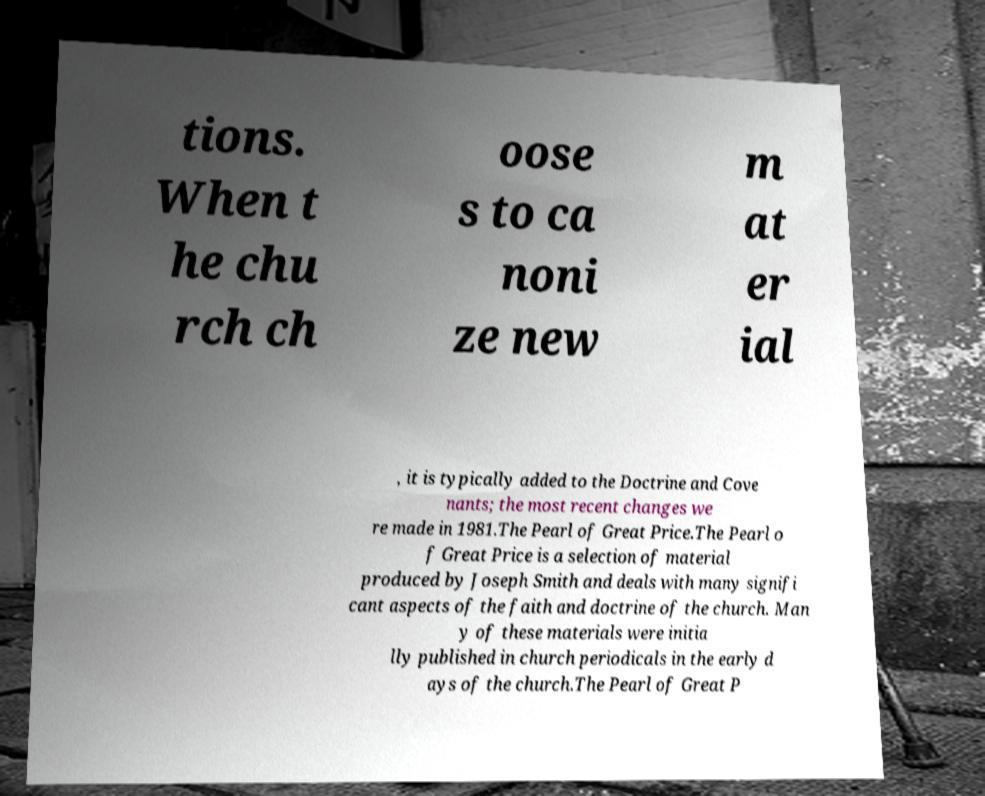I need the written content from this picture converted into text. Can you do that? tions. When t he chu rch ch oose s to ca noni ze new m at er ial , it is typically added to the Doctrine and Cove nants; the most recent changes we re made in 1981.The Pearl of Great Price.The Pearl o f Great Price is a selection of material produced by Joseph Smith and deals with many signifi cant aspects of the faith and doctrine of the church. Man y of these materials were initia lly published in church periodicals in the early d ays of the church.The Pearl of Great P 